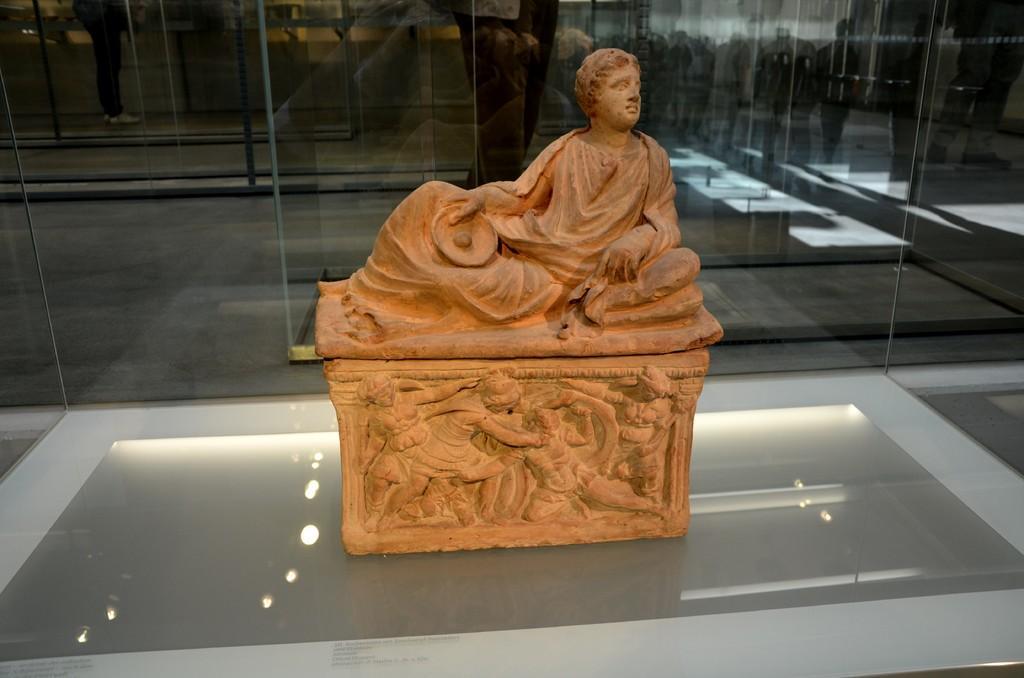Can you describe this image briefly? In the picture there is a statue present, behind the statue there are glass walls present. 